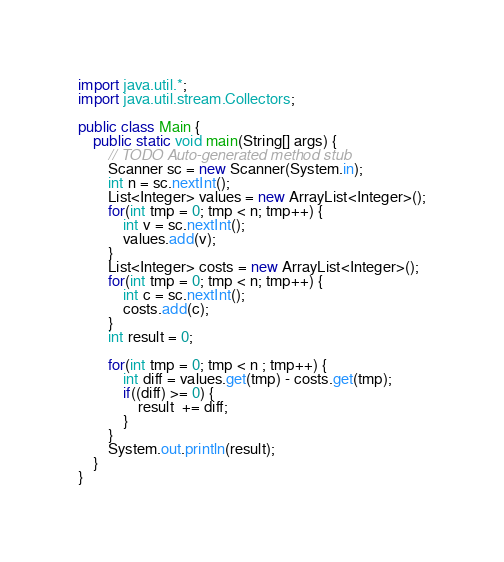Convert code to text. <code><loc_0><loc_0><loc_500><loc_500><_Java_>import java.util.*;
import java.util.stream.Collectors;

public class Main {
	public static void main(String[] args) {
		// TODO Auto-generated method stub
		Scanner sc = new Scanner(System.in);
		int n = sc.nextInt();
		List<Integer> values = new ArrayList<Integer>();
		for(int tmp = 0; tmp < n; tmp++) {
			int v = sc.nextInt();
			values.add(v);
		}
		List<Integer> costs = new ArrayList<Integer>();
		for(int tmp = 0; tmp < n; tmp++) {
			int c = sc.nextInt();
			costs.add(c);
		}
		int result = 0;
		
		for(int tmp = 0; tmp < n ; tmp++) {
			int diff = values.get(tmp) - costs.get(tmp);
			if((diff) >= 0) {
				result  += diff;
			}
		}
		System.out.println(result);	
	}
}</code> 